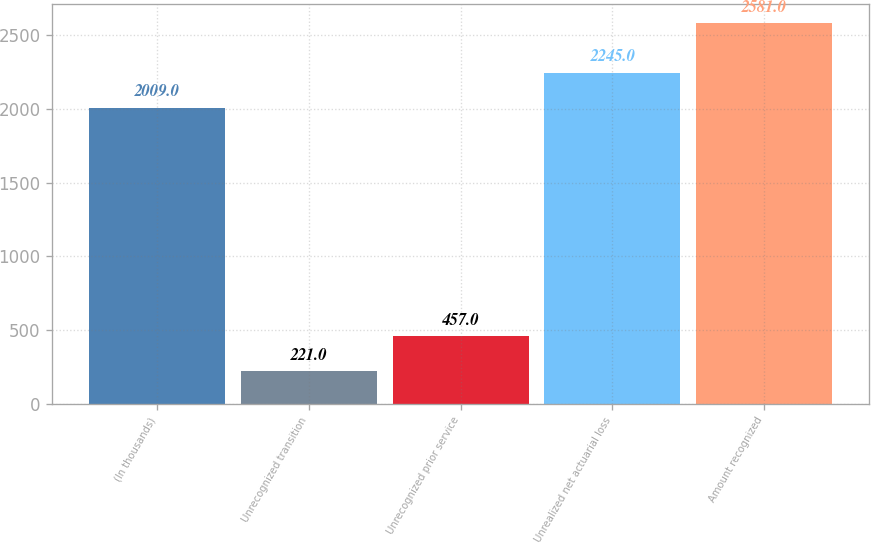Convert chart to OTSL. <chart><loc_0><loc_0><loc_500><loc_500><bar_chart><fcel>(In thousands)<fcel>Unrecognized transition<fcel>Unrecognized prior service<fcel>Unrealized net actuarial loss<fcel>Amount recognized<nl><fcel>2009<fcel>221<fcel>457<fcel>2245<fcel>2581<nl></chart> 